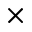<formula> <loc_0><loc_0><loc_500><loc_500>\times</formula> 